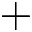Convert formula to latex. <formula><loc_0><loc_0><loc_500><loc_500>+</formula> 